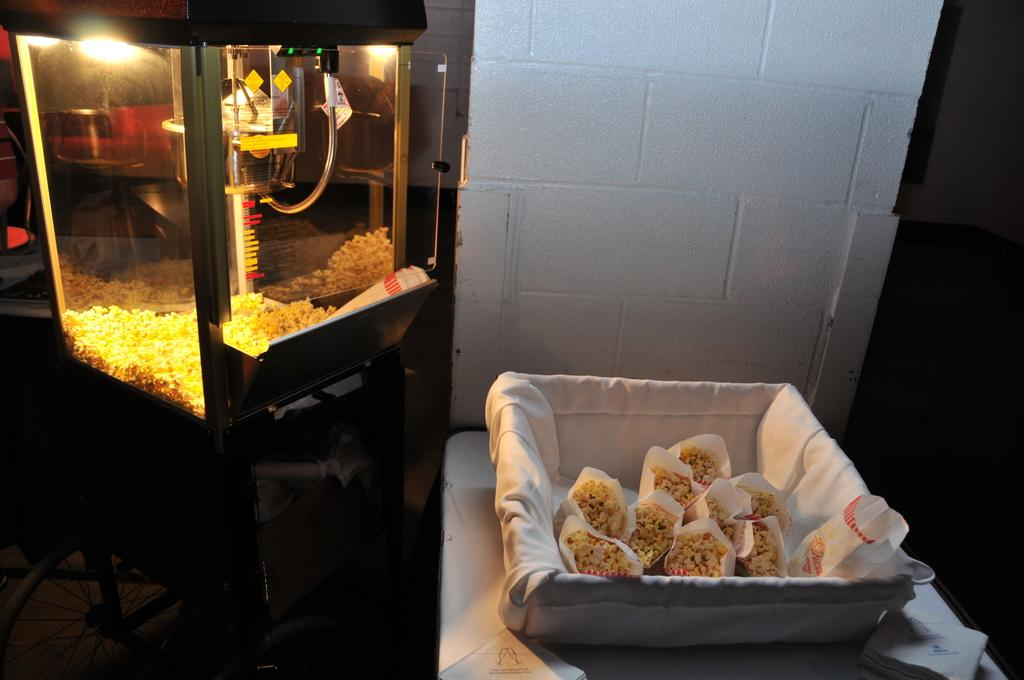What can be seen in the image that is used for making popcorn? There is a popcorn maker in the image. What part of the room can be seen in the image? The walls and floor are visible in the image. What is on the plate in the image? There is a plate containing popcorn packets in the image. What can be used for cleaning or wiping in the image? Paper napkins are present in the image. What circular object is visible in the image? There is a wheel in the image. What type of cream can be seen being mined in the image? There is no cream or mining activity present in the image. 